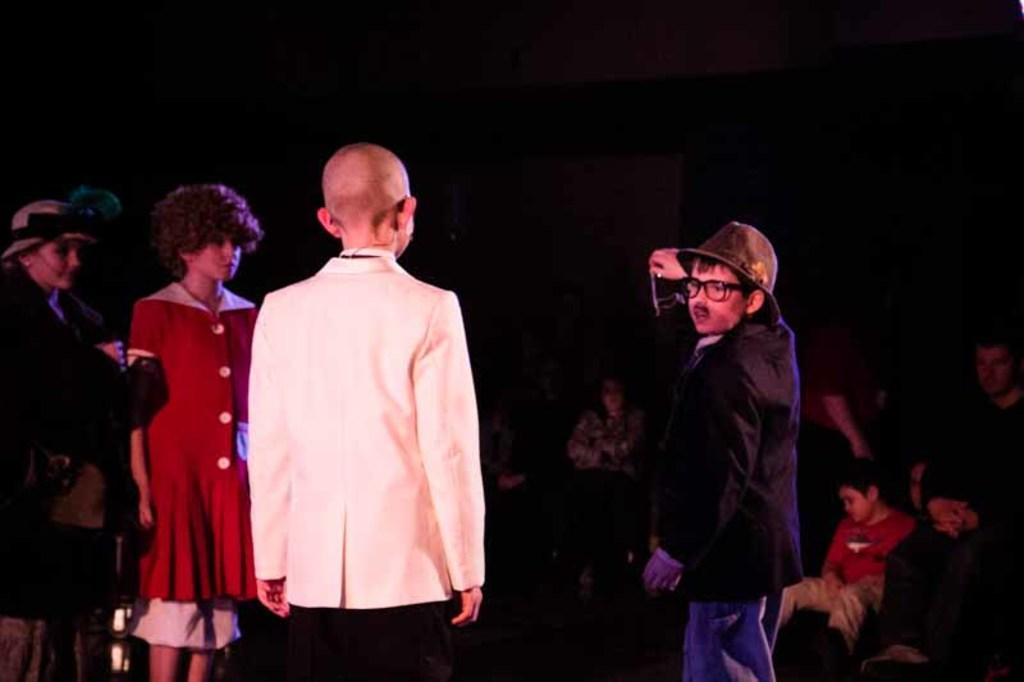What is happening in the image? There are people in the image, some of whom are standing and some of whom are sitting. Can you describe the positions of the people in the image? Some people are standing, while others are sitting. What can be observed about the background of the image? The background of the image is dark. What is the plot of the story being told by the pan in the image? There is no pan present in the image, and therefore no story being told by a pan. 